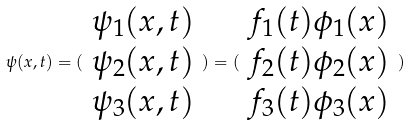<formula> <loc_0><loc_0><loc_500><loc_500>\psi ( x , t ) = ( \begin{array} { c } \psi _ { 1 } ( x , t ) \\ \psi _ { 2 } ( x , t ) \\ \psi _ { 3 } ( x , t ) \end{array} ) = ( \begin{array} { c } f _ { 1 } ( t ) \phi _ { 1 } ( x ) \\ f _ { 2 } ( t ) \phi _ { 2 } ( x ) \\ f _ { 3 } ( t ) \phi _ { 3 } ( x ) \end{array} )</formula> 